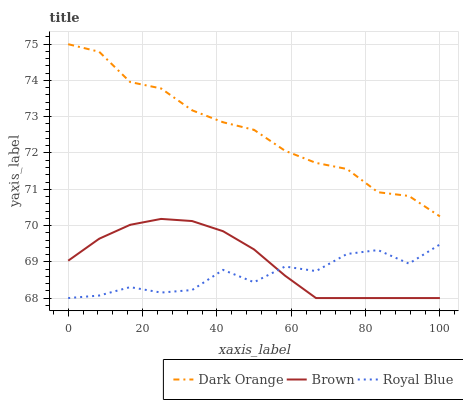Does Royal Blue have the minimum area under the curve?
Answer yes or no. Yes. Does Dark Orange have the maximum area under the curve?
Answer yes or no. Yes. Does Brown have the minimum area under the curve?
Answer yes or no. No. Does Brown have the maximum area under the curve?
Answer yes or no. No. Is Brown the smoothest?
Answer yes or no. Yes. Is Royal Blue the roughest?
Answer yes or no. Yes. Is Royal Blue the smoothest?
Answer yes or no. No. Is Brown the roughest?
Answer yes or no. No. Does Royal Blue have the lowest value?
Answer yes or no. Yes. Does Dark Orange have the highest value?
Answer yes or no. Yes. Does Brown have the highest value?
Answer yes or no. No. Is Brown less than Dark Orange?
Answer yes or no. Yes. Is Dark Orange greater than Royal Blue?
Answer yes or no. Yes. Does Royal Blue intersect Brown?
Answer yes or no. Yes. Is Royal Blue less than Brown?
Answer yes or no. No. Is Royal Blue greater than Brown?
Answer yes or no. No. Does Brown intersect Dark Orange?
Answer yes or no. No. 